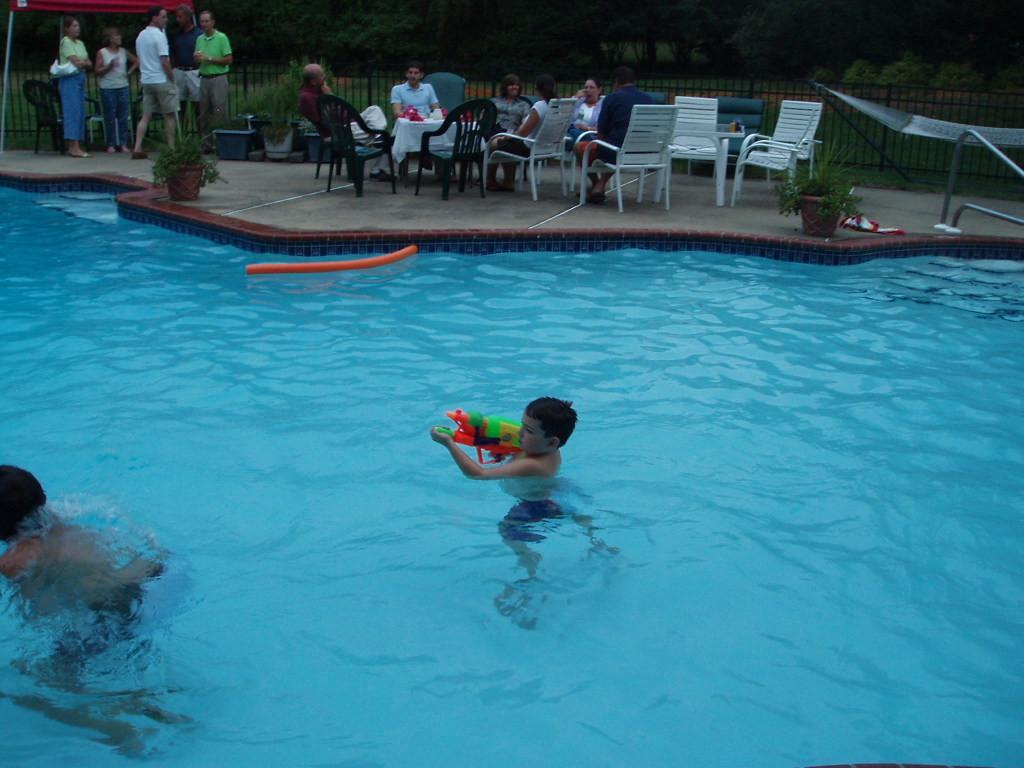Could you give a brief overview of what you see in this image? In this image we can see a few people, among them some are standing and some are sitting on the chairs, we can see two kids in the swimming pool among them one is holding an object, there are some trees, plants and fence. 